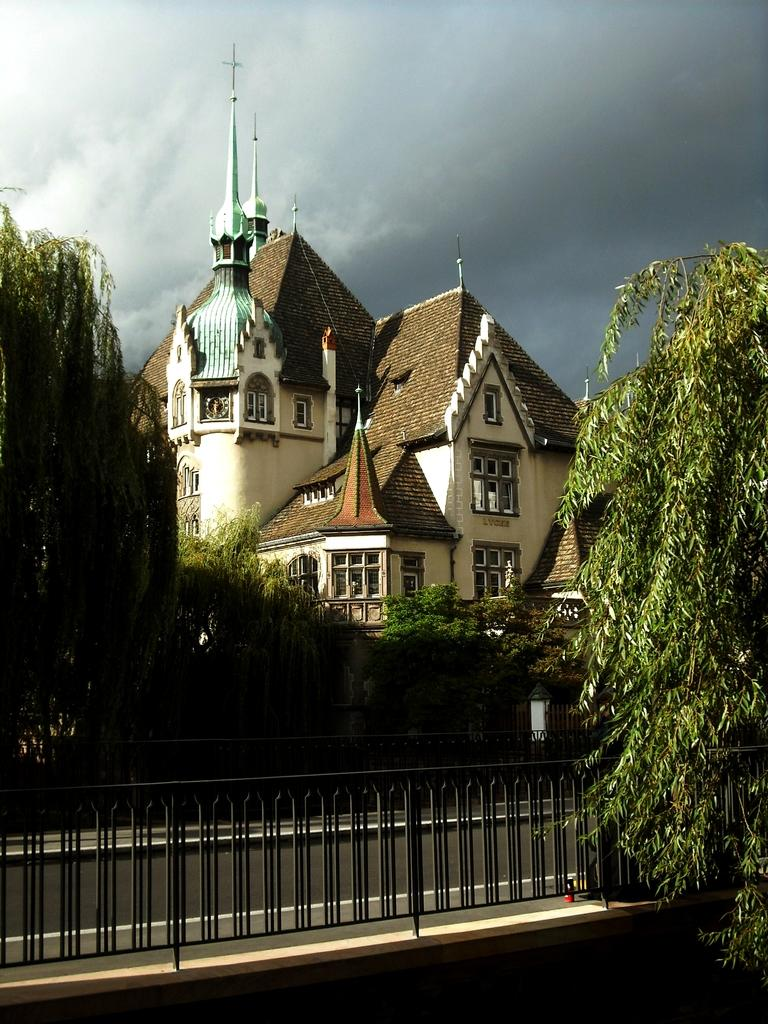What type of structure is present in the image? There is a building in the image. What type of vegetation is visible in the image? There are trees in the image. What type of barrier is present in the image? There is a fence in the image. Can you see a request written in chalk in the image? There is no request written in chalk present in the image. Is there a walkway or path visible in the image? The provided facts do not mention a walkway or path, so it cannot be determined from the image. 